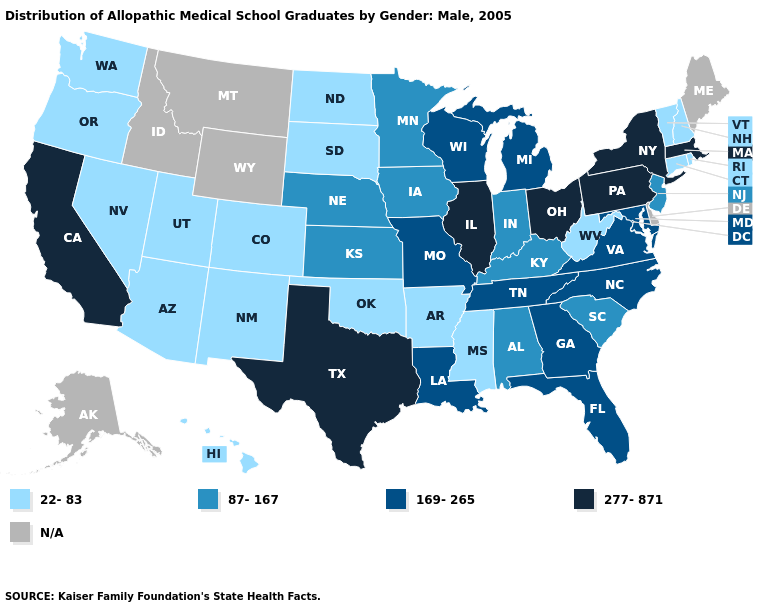Name the states that have a value in the range 169-265?
Quick response, please. Florida, Georgia, Louisiana, Maryland, Michigan, Missouri, North Carolina, Tennessee, Virginia, Wisconsin. Among the states that border Virginia , which have the lowest value?
Write a very short answer. West Virginia. Name the states that have a value in the range 169-265?
Be succinct. Florida, Georgia, Louisiana, Maryland, Michigan, Missouri, North Carolina, Tennessee, Virginia, Wisconsin. Which states have the lowest value in the South?
Answer briefly. Arkansas, Mississippi, Oklahoma, West Virginia. What is the value of Massachusetts?
Keep it brief. 277-871. Is the legend a continuous bar?
Write a very short answer. No. Name the states that have a value in the range 87-167?
Keep it brief. Alabama, Indiana, Iowa, Kansas, Kentucky, Minnesota, Nebraska, New Jersey, South Carolina. Which states hav the highest value in the South?
Be succinct. Texas. Name the states that have a value in the range 277-871?
Short answer required. California, Illinois, Massachusetts, New York, Ohio, Pennsylvania, Texas. What is the highest value in states that border Illinois?
Quick response, please. 169-265. Does Colorado have the highest value in the West?
Short answer required. No. What is the value of Washington?
Answer briefly. 22-83. Name the states that have a value in the range 277-871?
Short answer required. California, Illinois, Massachusetts, New York, Ohio, Pennsylvania, Texas. Name the states that have a value in the range 169-265?
Concise answer only. Florida, Georgia, Louisiana, Maryland, Michigan, Missouri, North Carolina, Tennessee, Virginia, Wisconsin. 